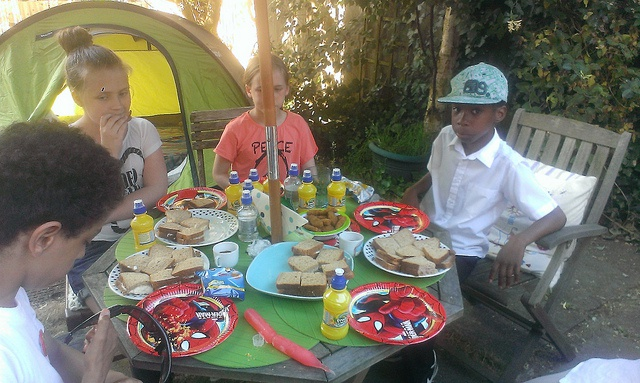Describe the objects in this image and their specific colors. I can see sandwich in white, gray, darkgray, and black tones, dining table in white, gray, darkgray, green, and brown tones, people in white, black, gray, and lightblue tones, people in white, gray, darkgray, and lightblue tones, and chair in white, gray, black, and purple tones in this image. 